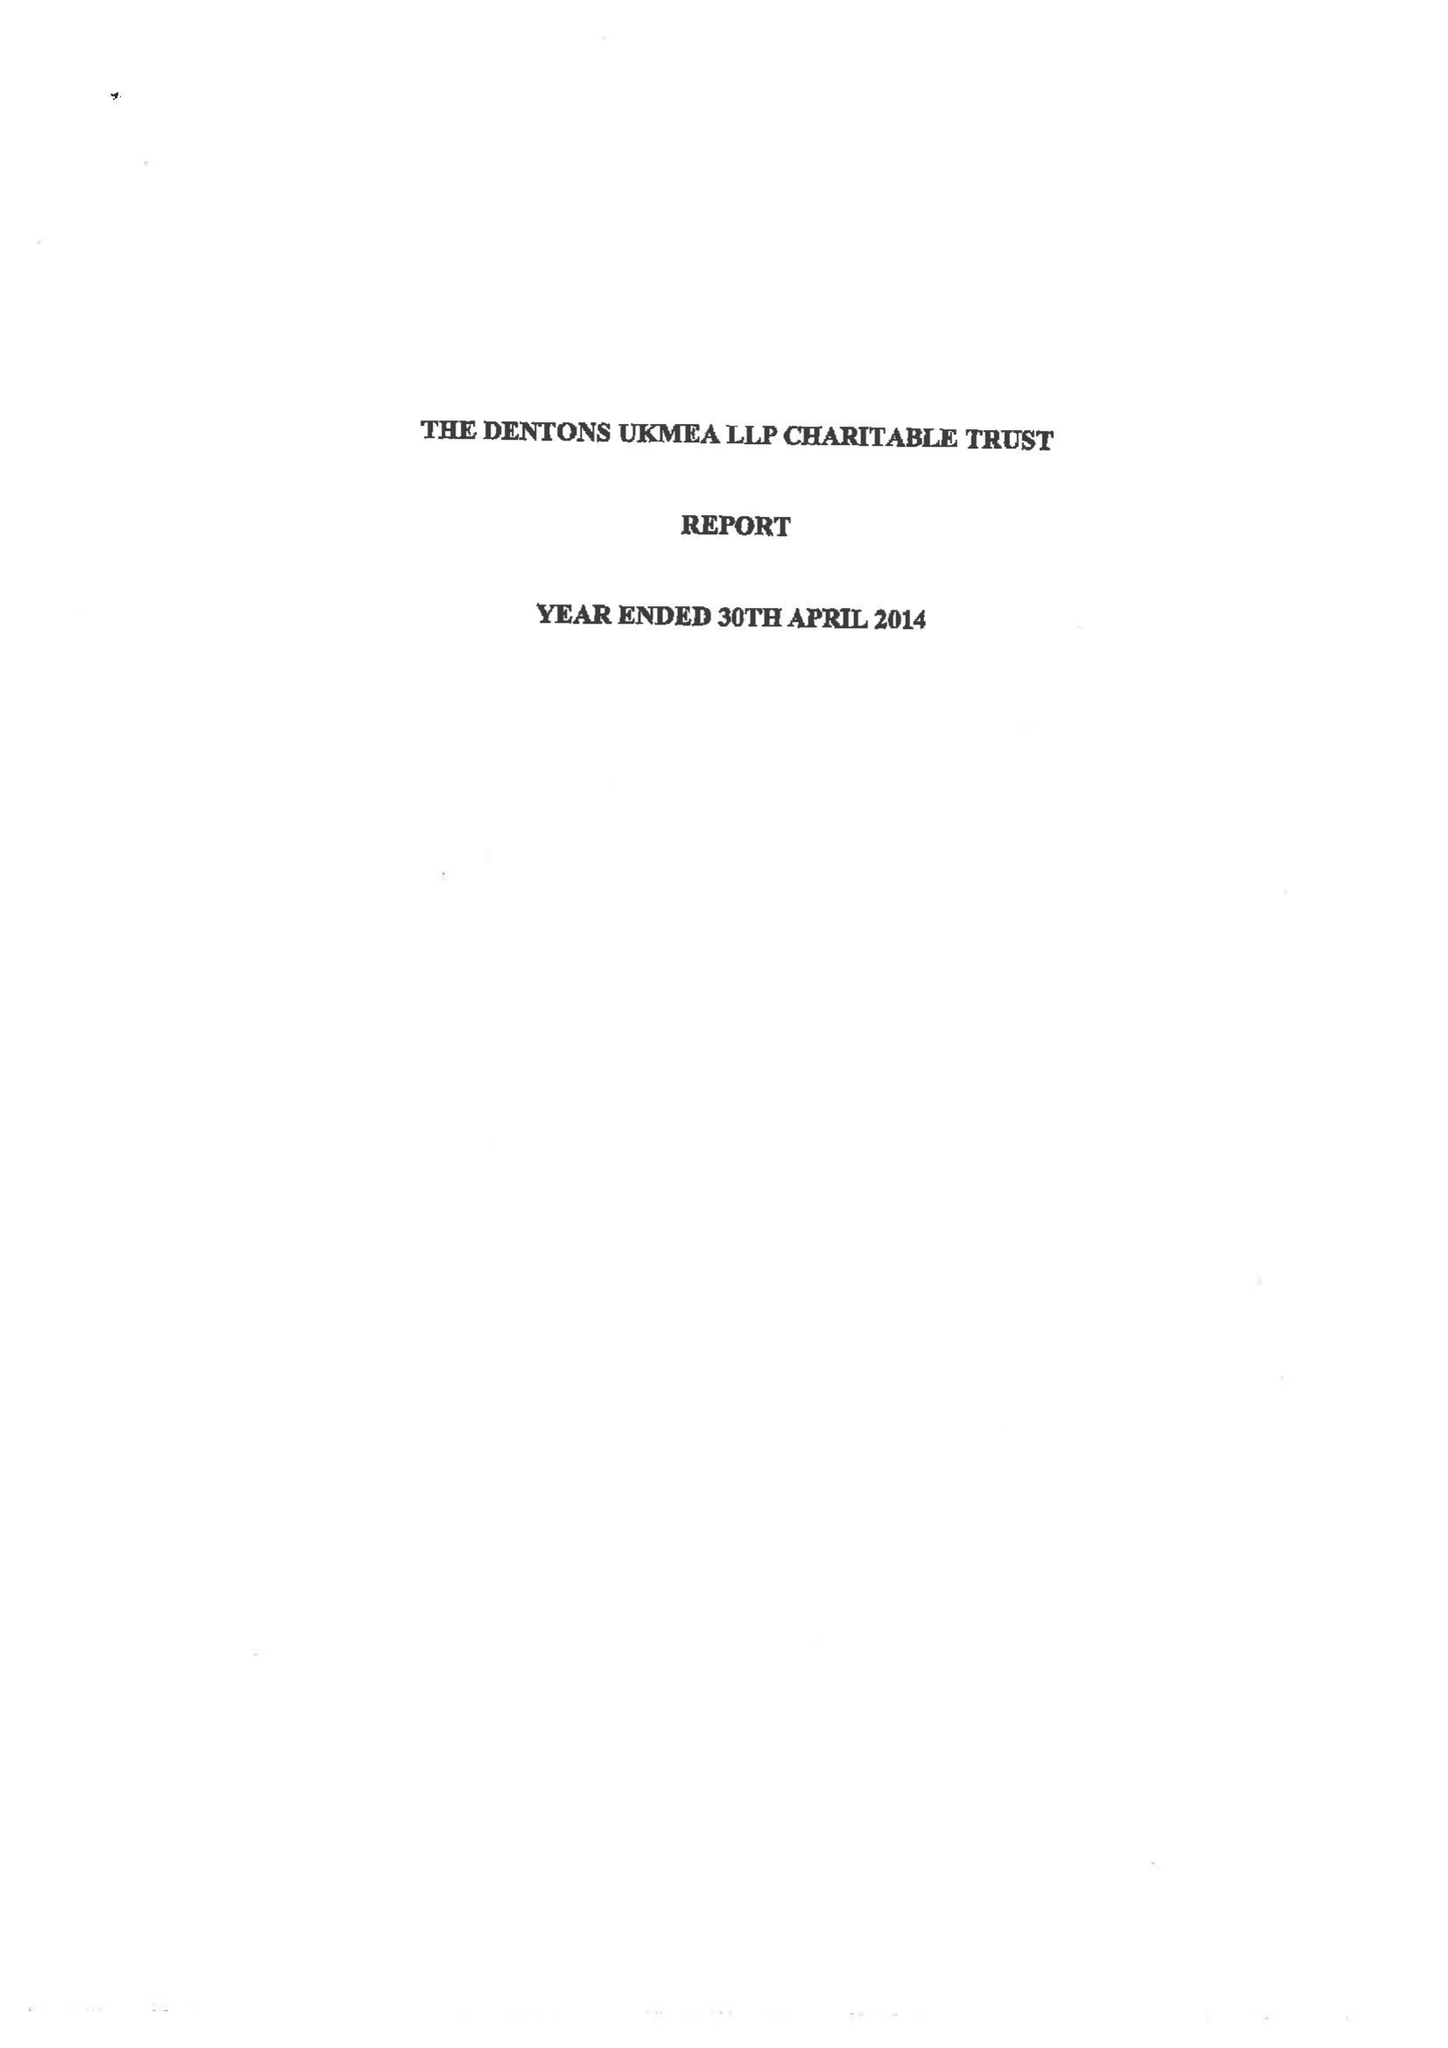What is the value for the income_annually_in_british_pounds?
Answer the question using a single word or phrase. 93765.00 